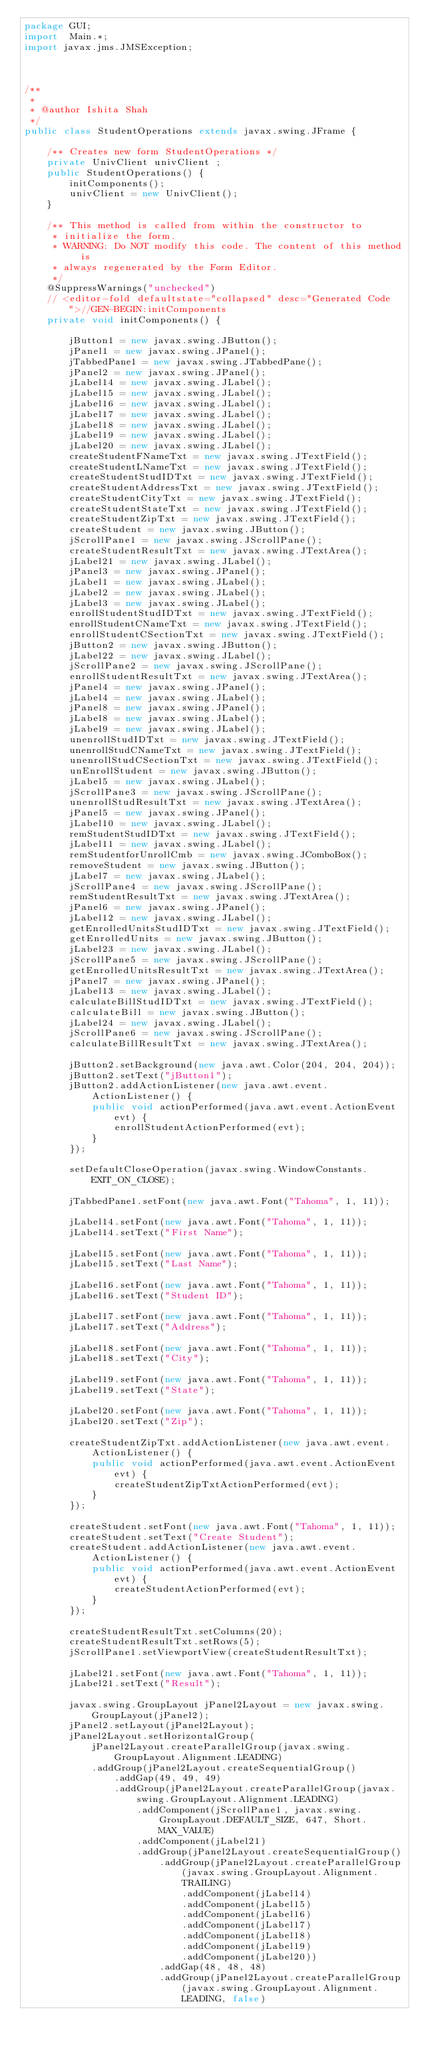Convert code to text. <code><loc_0><loc_0><loc_500><loc_500><_Java_>package GUI;
import  Main.*;
import javax.jms.JMSException;



/**
 *
 * @author Ishita Shah
 */
public class StudentOperations extends javax.swing.JFrame {

    /** Creates new form StudentOperations */
	private UnivClient univClient ;
    public StudentOperations() {
        initComponents();
        univClient = new UnivClient();
    }

    /** This method is called from within the constructor to
     * initialize the form.
     * WARNING: Do NOT modify this code. The content of this method is
     * always regenerated by the Form Editor.
     */
    @SuppressWarnings("unchecked")
    // <editor-fold defaultstate="collapsed" desc="Generated Code">//GEN-BEGIN:initComponents
    private void initComponents() {

        jButton1 = new javax.swing.JButton();
        jPanel1 = new javax.swing.JPanel();
        jTabbedPane1 = new javax.swing.JTabbedPane();
        jPanel2 = new javax.swing.JPanel();
        jLabel14 = new javax.swing.JLabel();
        jLabel15 = new javax.swing.JLabel();
        jLabel16 = new javax.swing.JLabel();
        jLabel17 = new javax.swing.JLabel();
        jLabel18 = new javax.swing.JLabel();
        jLabel19 = new javax.swing.JLabel();
        jLabel20 = new javax.swing.JLabel();
        createStudentFNameTxt = new javax.swing.JTextField();
        createStudentLNameTxt = new javax.swing.JTextField();
        createStudentStudIDTxt = new javax.swing.JTextField();
        createStudentAddressTxt = new javax.swing.JTextField();
        createStudentCityTxt = new javax.swing.JTextField();
        createStudentStateTxt = new javax.swing.JTextField();
        createStudentZipTxt = new javax.swing.JTextField();
        createStudent = new javax.swing.JButton();
        jScrollPane1 = new javax.swing.JScrollPane();
        createStudentResultTxt = new javax.swing.JTextArea();
        jLabel21 = new javax.swing.JLabel();
        jPanel3 = new javax.swing.JPanel();
        jLabel1 = new javax.swing.JLabel();
        jLabel2 = new javax.swing.JLabel();
        jLabel3 = new javax.swing.JLabel();
        enrollStudentStudIDTxt = new javax.swing.JTextField();
        enrollStudentCNameTxt = new javax.swing.JTextField();
        enrollStudentCSectionTxt = new javax.swing.JTextField();
        jButton2 = new javax.swing.JButton();
        jLabel22 = new javax.swing.JLabel();
        jScrollPane2 = new javax.swing.JScrollPane();
        enrollStudentResultTxt = new javax.swing.JTextArea();
        jPanel4 = new javax.swing.JPanel();
        jLabel4 = new javax.swing.JLabel();
        jPanel8 = new javax.swing.JPanel();
        jLabel8 = new javax.swing.JLabel();
        jLabel9 = new javax.swing.JLabel();
        unenrollStudIDTxt = new javax.swing.JTextField();
        unenrollStudCNameTxt = new javax.swing.JTextField();
        unenrollStudCSectionTxt = new javax.swing.JTextField();
        unEnrollStudent = new javax.swing.JButton();
        jLabel5 = new javax.swing.JLabel();
        jScrollPane3 = new javax.swing.JScrollPane();
        unenrollStudResultTxt = new javax.swing.JTextArea();
        jPanel5 = new javax.swing.JPanel();
        jLabel10 = new javax.swing.JLabel();
        remStudentStudIDTxt = new javax.swing.JTextField();
        jLabel11 = new javax.swing.JLabel();
        remStudentforUnrollCmb = new javax.swing.JComboBox();
        removeStudent = new javax.swing.JButton();
        jLabel7 = new javax.swing.JLabel();
        jScrollPane4 = new javax.swing.JScrollPane();
        remStudentResultTxt = new javax.swing.JTextArea();
        jPanel6 = new javax.swing.JPanel();
        jLabel12 = new javax.swing.JLabel();
        getEnrolledUnitsStudIDTxt = new javax.swing.JTextField();
        getEnrolledUnits = new javax.swing.JButton();
        jLabel23 = new javax.swing.JLabel();
        jScrollPane5 = new javax.swing.JScrollPane();
        getEnrolledUnitsResultTxt = new javax.swing.JTextArea();
        jPanel7 = new javax.swing.JPanel();
        jLabel13 = new javax.swing.JLabel();
        calculateBillStudIDTxt = new javax.swing.JTextField();
        calculateBill = new javax.swing.JButton();
        jLabel24 = new javax.swing.JLabel();
        jScrollPane6 = new javax.swing.JScrollPane();
        calculateBillResultTxt = new javax.swing.JTextArea();

        jButton2.setBackground(new java.awt.Color(204, 204, 204));
        jButton2.setText("jButton1");
        jButton2.addActionListener(new java.awt.event.ActionListener() {
            public void actionPerformed(java.awt.event.ActionEvent evt) {
                enrollStudentActionPerformed(evt);
            }
        });

        setDefaultCloseOperation(javax.swing.WindowConstants.EXIT_ON_CLOSE);

        jTabbedPane1.setFont(new java.awt.Font("Tahoma", 1, 11));

        jLabel14.setFont(new java.awt.Font("Tahoma", 1, 11));
        jLabel14.setText("First Name");

        jLabel15.setFont(new java.awt.Font("Tahoma", 1, 11));
        jLabel15.setText("Last Name");

        jLabel16.setFont(new java.awt.Font("Tahoma", 1, 11));
        jLabel16.setText("Student ID");

        jLabel17.setFont(new java.awt.Font("Tahoma", 1, 11));
        jLabel17.setText("Address");

        jLabel18.setFont(new java.awt.Font("Tahoma", 1, 11));
        jLabel18.setText("City");

        jLabel19.setFont(new java.awt.Font("Tahoma", 1, 11));
        jLabel19.setText("State");

        jLabel20.setFont(new java.awt.Font("Tahoma", 1, 11));
        jLabel20.setText("Zip");

        createStudentZipTxt.addActionListener(new java.awt.event.ActionListener() {
            public void actionPerformed(java.awt.event.ActionEvent evt) {
                createStudentZipTxtActionPerformed(evt);
            }
        });

        createStudent.setFont(new java.awt.Font("Tahoma", 1, 11));
        createStudent.setText("Create Student");
        createStudent.addActionListener(new java.awt.event.ActionListener() {
            public void actionPerformed(java.awt.event.ActionEvent evt) {
                createStudentActionPerformed(evt);
            }
        });

        createStudentResultTxt.setColumns(20);
        createStudentResultTxt.setRows(5);
        jScrollPane1.setViewportView(createStudentResultTxt);

        jLabel21.setFont(new java.awt.Font("Tahoma", 1, 11));
        jLabel21.setText("Result");

        javax.swing.GroupLayout jPanel2Layout = new javax.swing.GroupLayout(jPanel2);
        jPanel2.setLayout(jPanel2Layout);
        jPanel2Layout.setHorizontalGroup(
            jPanel2Layout.createParallelGroup(javax.swing.GroupLayout.Alignment.LEADING)
            .addGroup(jPanel2Layout.createSequentialGroup()
                .addGap(49, 49, 49)
                .addGroup(jPanel2Layout.createParallelGroup(javax.swing.GroupLayout.Alignment.LEADING)
                    .addComponent(jScrollPane1, javax.swing.GroupLayout.DEFAULT_SIZE, 647, Short.MAX_VALUE)
                    .addComponent(jLabel21)
                    .addGroup(jPanel2Layout.createSequentialGroup()
                        .addGroup(jPanel2Layout.createParallelGroup(javax.swing.GroupLayout.Alignment.TRAILING)
                            .addComponent(jLabel14)
                            .addComponent(jLabel15)
                            .addComponent(jLabel16)
                            .addComponent(jLabel17)
                            .addComponent(jLabel18)
                            .addComponent(jLabel19)
                            .addComponent(jLabel20))
                        .addGap(48, 48, 48)
                        .addGroup(jPanel2Layout.createParallelGroup(javax.swing.GroupLayout.Alignment.LEADING, false)</code> 